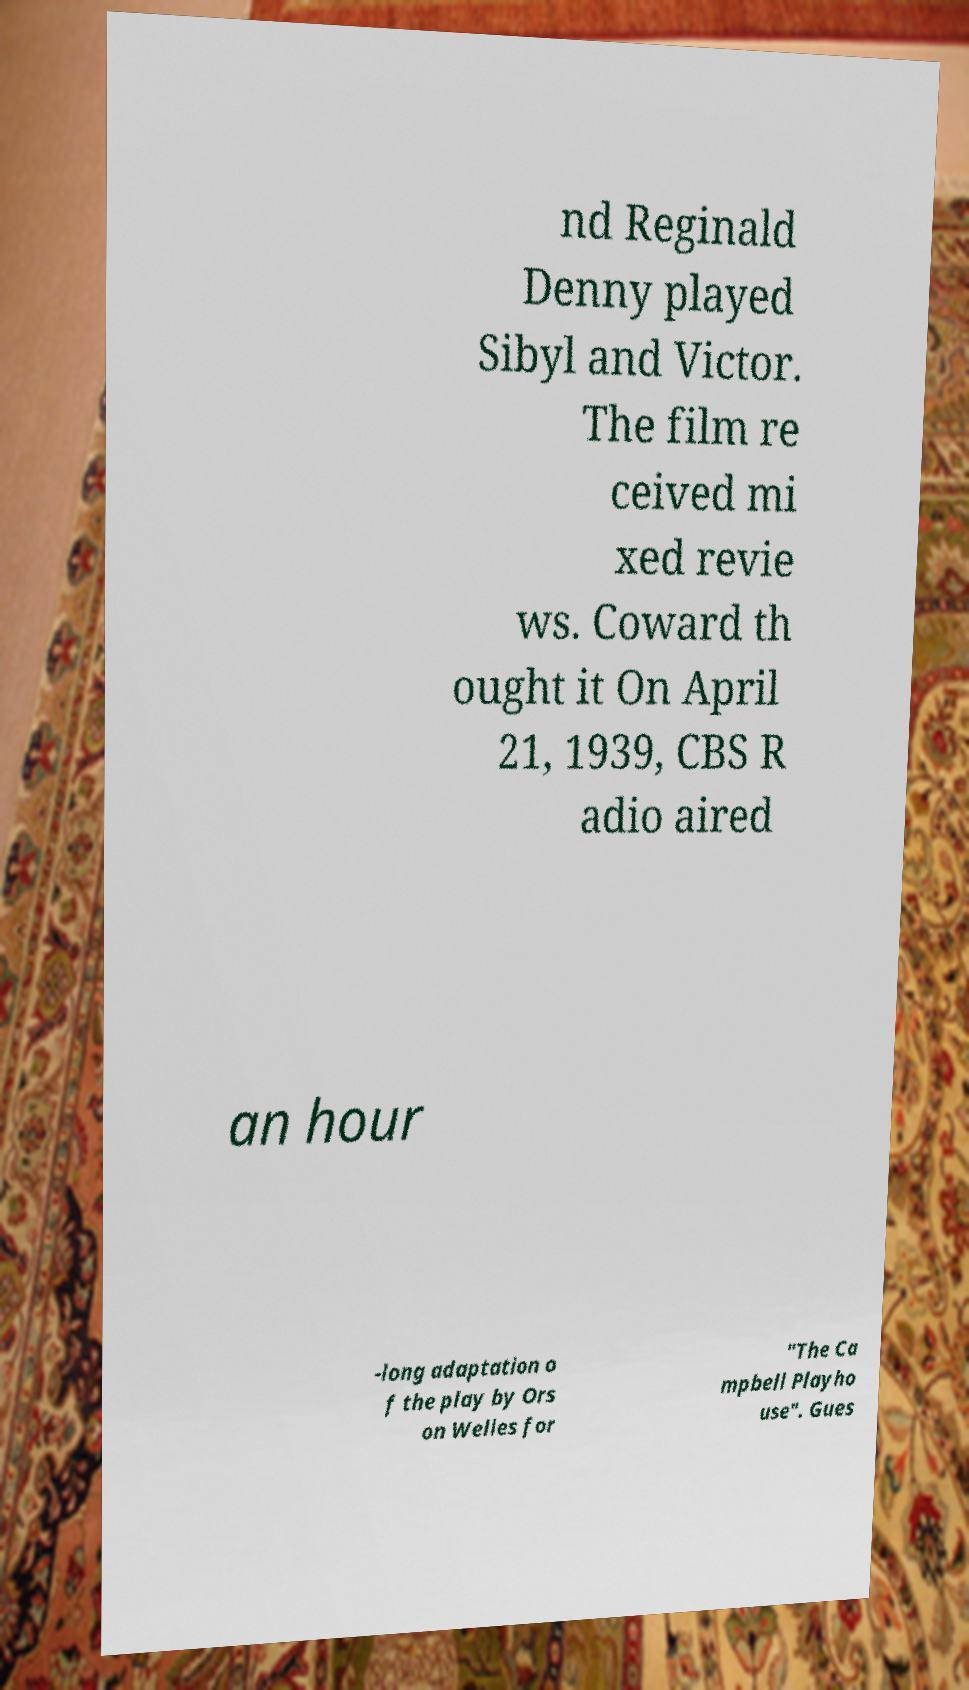Could you extract and type out the text from this image? nd Reginald Denny played Sibyl and Victor. The film re ceived mi xed revie ws. Coward th ought it On April 21, 1939, CBS R adio aired an hour -long adaptation o f the play by Ors on Welles for "The Ca mpbell Playho use". Gues 